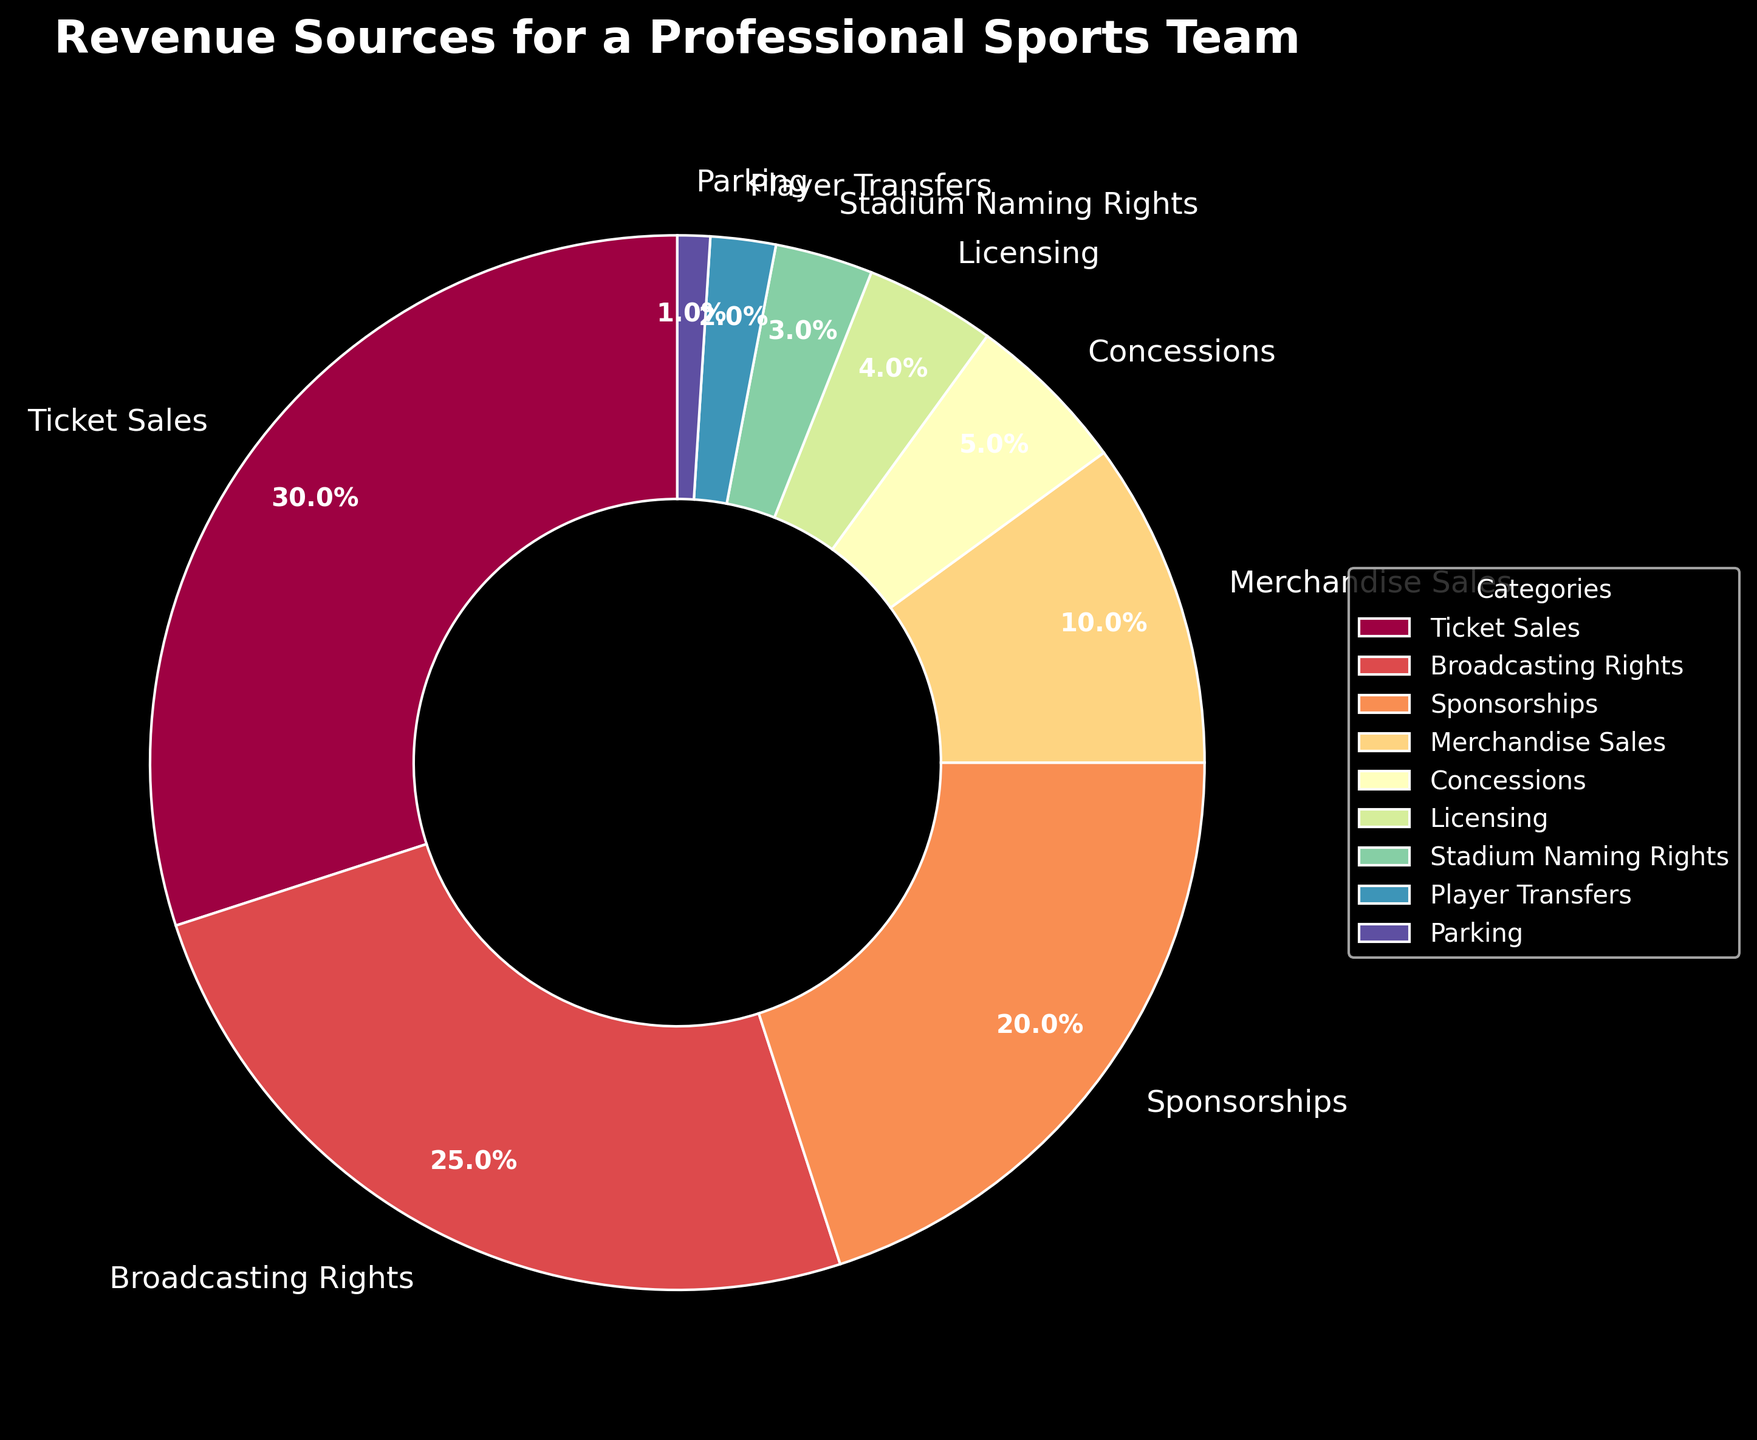What is the largest revenue source for the professional sports team? The largest slice of the pie chart corresponds to Ticket Sales with 30%, indicating that it is the largest revenue source.
Answer: Ticket Sales Which revenue source contributes the least? The smallest slice of the pie chart corresponds to Parking with 1%, making it the least contributing revenue source.
Answer: Parking How much more does Ticket Sales contribute compared to Broadcasting Rights? Ticket Sales contribute 30%, while Broadcasting Rights contribute 25%. The difference between them is 30% - 25%.
Answer: 5% What are the combined percentages of Merchandise Sales and Concessions? Merchandise Sales contribute 10%, and Concessions contribute 5%. Their combined percentage is 10% + 5%.
Answer: 15% Which revenue sources contribute more than 20%? The slices representing revenues contributing more than 20% are Ticket Sales with 30% and Broadcasting Rights with 25%.
Answer: Ticket Sales and Broadcasting Rights Compare the contributions of Sponsorships and Merchandise Sales. Sponsorships contribute 20%, whereas Merchandise Sales contribute 10%. Sponsorships contribute more.
Answer: Sponsorships contribute more What percentage of revenue comes from sources other than Ticket Sales and Broadcasting Rights? First, sum the contributions from Ticket Sales (30%) and Broadcasting Rights (25%), which equals 55%. Then subtract this from 100% to find the percentage from other sources, 100% - 55%.
Answer: 45% How does the percentage from Licensing compare with the percentage from Stadium Naming Rights? Licensing contributes 4%, while Stadium Naming Rights contribute 3%. Licensing contributes more.
Answer: Licensing contributes more Sum the percentages of the four smallest revenue sources. The smallest revenue sources are Parking (1%), Player Transfers (2%), Stadium Naming Rights (3%), and Licensing (4%). Their sum is 1% + 2% + 3% + 4%.
Answer: 10% Which revenue source's percentage is closest to the percentage of Concessions? Concessions contribute 5%, and the closest percentage is Licensing which contributes 4%.
Answer: Licensing 